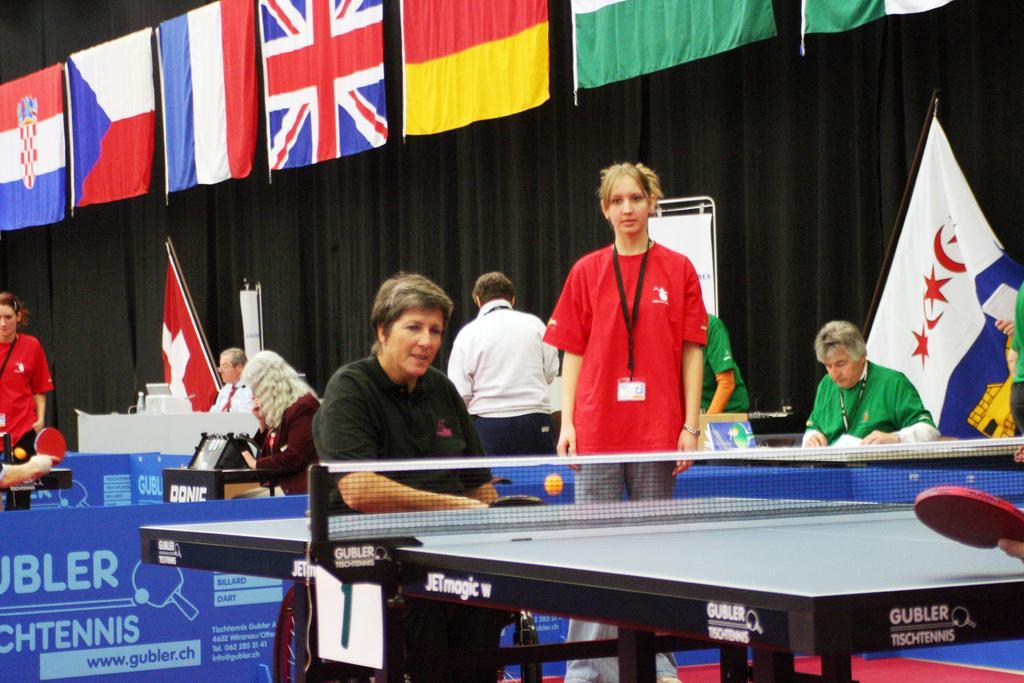Please provide a concise description of this image. In this image there are group of persons. The person who is wearing a black T-shirt sitting near the table tennis court and at the top of the image there are different national flags and at the bottom right of the image there is a table tennis racket. 